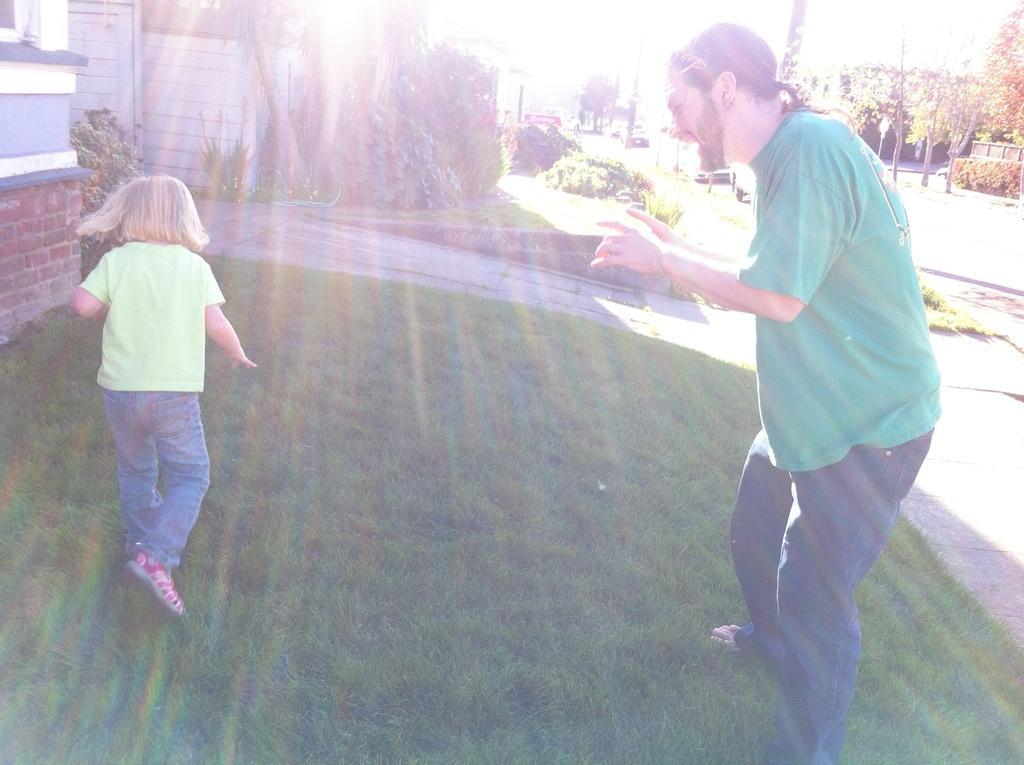Can you describe this image briefly? There is a man and a small girl on the grassland in the foreground area of the image, there are houses, trees, poles and the sky in the background. 